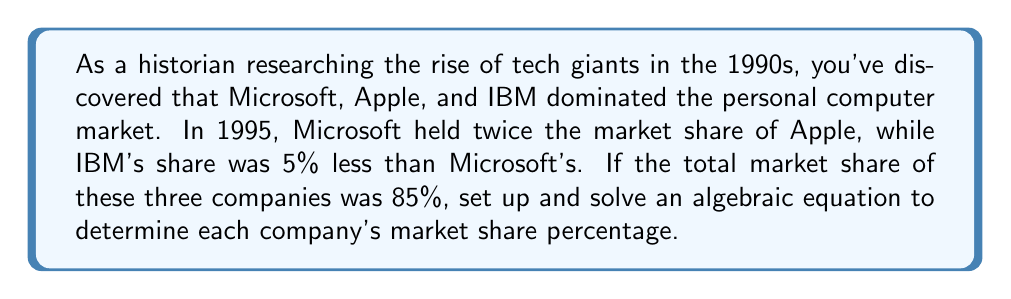Can you solve this math problem? Let's approach this step-by-step:

1) Let's define our variables:
   $x$ = Apple's market share
   $2x$ = Microsoft's market share (twice Apple's)
   $(2x - 5)$ = IBM's market share (5% less than Microsoft's)

2) We know that the total market share of these three companies is 85%. We can set up an equation:

   $x + 2x + (2x - 5) = 85$

3) Simplify the left side of the equation:

   $5x - 5 = 85$

4) Add 5 to both sides:

   $5x = 90$

5) Divide both sides by 5:

   $x = 18$

6) Now that we know Apple's share ($x$), we can calculate the others:
   
   Apple: $x = 18\%$
   Microsoft: $2x = 2(18) = 36\%$
   IBM: $2x - 5 = 36 - 5 = 31\%$

7) Verify: $18\% + 36\% + 31\% = 85\%$
Answer: Apple's market share: 18%
Microsoft's market share: 36%
IBM's market share: 31% 